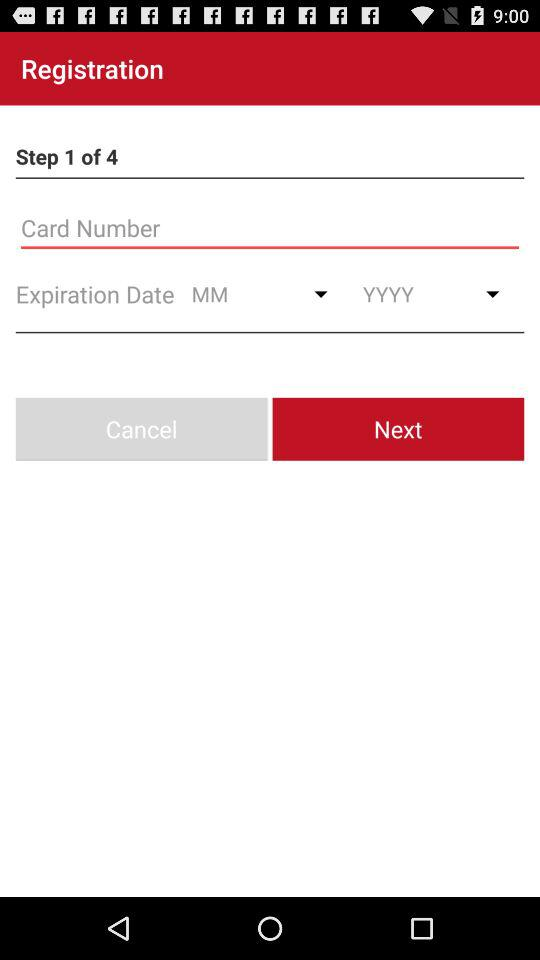How many steps in total are there? There are 4 steps in total. 